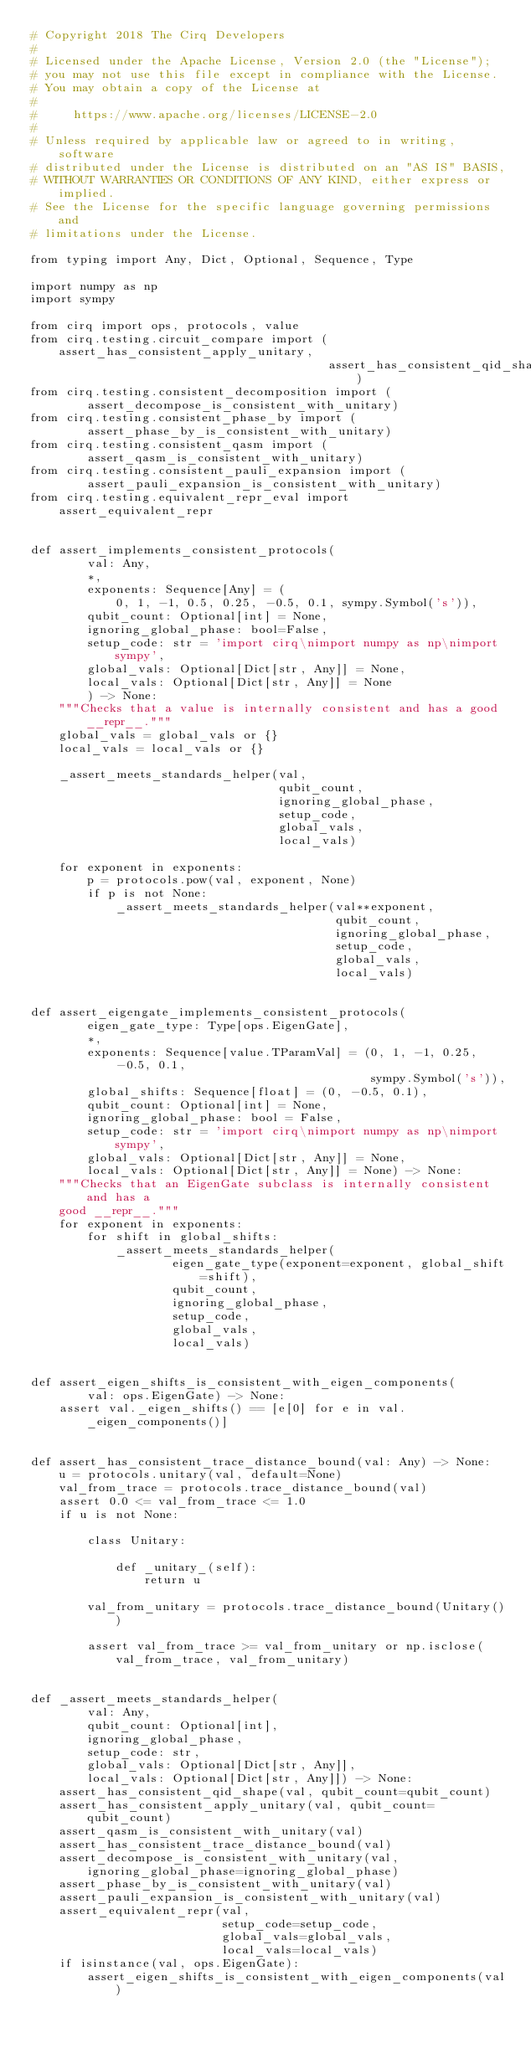Convert code to text. <code><loc_0><loc_0><loc_500><loc_500><_Python_># Copyright 2018 The Cirq Developers
#
# Licensed under the Apache License, Version 2.0 (the "License");
# you may not use this file except in compliance with the License.
# You may obtain a copy of the License at
#
#     https://www.apache.org/licenses/LICENSE-2.0
#
# Unless required by applicable law or agreed to in writing, software
# distributed under the License is distributed on an "AS IS" BASIS,
# WITHOUT WARRANTIES OR CONDITIONS OF ANY KIND, either express or implied.
# See the License for the specific language governing permissions and
# limitations under the License.

from typing import Any, Dict, Optional, Sequence, Type

import numpy as np
import sympy

from cirq import ops, protocols, value
from cirq.testing.circuit_compare import (assert_has_consistent_apply_unitary,
                                          assert_has_consistent_qid_shape)
from cirq.testing.consistent_decomposition import (
        assert_decompose_is_consistent_with_unitary)
from cirq.testing.consistent_phase_by import (
        assert_phase_by_is_consistent_with_unitary)
from cirq.testing.consistent_qasm import (
        assert_qasm_is_consistent_with_unitary)
from cirq.testing.consistent_pauli_expansion import (
        assert_pauli_expansion_is_consistent_with_unitary)
from cirq.testing.equivalent_repr_eval import assert_equivalent_repr


def assert_implements_consistent_protocols(
        val: Any,
        *,
        exponents: Sequence[Any] = (
            0, 1, -1, 0.5, 0.25, -0.5, 0.1, sympy.Symbol('s')),
        qubit_count: Optional[int] = None,
        ignoring_global_phase: bool=False,
        setup_code: str = 'import cirq\nimport numpy as np\nimport sympy',
        global_vals: Optional[Dict[str, Any]] = None,
        local_vals: Optional[Dict[str, Any]] = None
        ) -> None:
    """Checks that a value is internally consistent and has a good __repr__."""
    global_vals = global_vals or {}
    local_vals = local_vals or {}

    _assert_meets_standards_helper(val,
                                   qubit_count,
                                   ignoring_global_phase,
                                   setup_code,
                                   global_vals,
                                   local_vals)

    for exponent in exponents:
        p = protocols.pow(val, exponent, None)
        if p is not None:
            _assert_meets_standards_helper(val**exponent,
                                           qubit_count,
                                           ignoring_global_phase,
                                           setup_code,
                                           global_vals,
                                           local_vals)


def assert_eigengate_implements_consistent_protocols(
        eigen_gate_type: Type[ops.EigenGate],
        *,
        exponents: Sequence[value.TParamVal] = (0, 1, -1, 0.25, -0.5, 0.1,
                                                sympy.Symbol('s')),
        global_shifts: Sequence[float] = (0, -0.5, 0.1),
        qubit_count: Optional[int] = None,
        ignoring_global_phase: bool = False,
        setup_code: str = 'import cirq\nimport numpy as np\nimport sympy',
        global_vals: Optional[Dict[str, Any]] = None,
        local_vals: Optional[Dict[str, Any]] = None) -> None:
    """Checks that an EigenGate subclass is internally consistent and has a
    good __repr__."""
    for exponent in exponents:
        for shift in global_shifts:
            _assert_meets_standards_helper(
                    eigen_gate_type(exponent=exponent, global_shift=shift),
                    qubit_count,
                    ignoring_global_phase,
                    setup_code,
                    global_vals,
                    local_vals)


def assert_eigen_shifts_is_consistent_with_eigen_components(
        val: ops.EigenGate) -> None:
    assert val._eigen_shifts() == [e[0] for e in val._eigen_components()]


def assert_has_consistent_trace_distance_bound(val: Any) -> None:
    u = protocols.unitary(val, default=None)
    val_from_trace = protocols.trace_distance_bound(val)
    assert 0.0 <= val_from_trace <= 1.0
    if u is not None:

        class Unitary:

            def _unitary_(self):
                return u

        val_from_unitary = protocols.trace_distance_bound(Unitary())

        assert val_from_trace >= val_from_unitary or np.isclose(
            val_from_trace, val_from_unitary)


def _assert_meets_standards_helper(
        val: Any,
        qubit_count: Optional[int],
        ignoring_global_phase,
        setup_code: str,
        global_vals: Optional[Dict[str, Any]],
        local_vals: Optional[Dict[str, Any]]) -> None:
    assert_has_consistent_qid_shape(val, qubit_count=qubit_count)
    assert_has_consistent_apply_unitary(val, qubit_count=qubit_count)
    assert_qasm_is_consistent_with_unitary(val)
    assert_has_consistent_trace_distance_bound(val)
    assert_decompose_is_consistent_with_unitary(val,
        ignoring_global_phase=ignoring_global_phase)
    assert_phase_by_is_consistent_with_unitary(val)
    assert_pauli_expansion_is_consistent_with_unitary(val)
    assert_equivalent_repr(val,
                           setup_code=setup_code,
                           global_vals=global_vals,
                           local_vals=local_vals)
    if isinstance(val, ops.EigenGate):
        assert_eigen_shifts_is_consistent_with_eigen_components(val)
</code> 